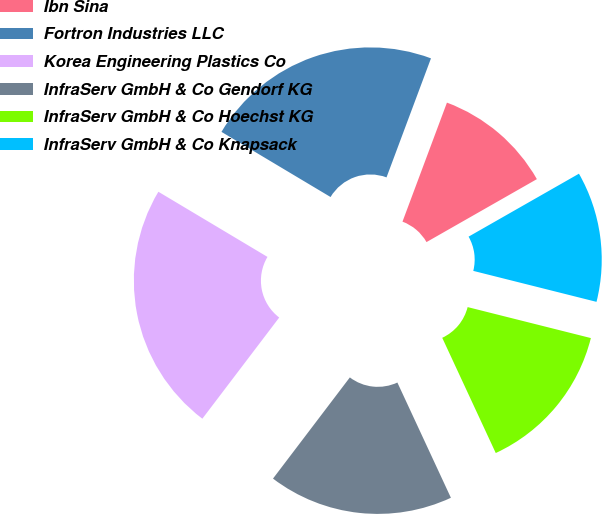<chart> <loc_0><loc_0><loc_500><loc_500><pie_chart><fcel>Ibn Sina<fcel>Fortron Industries LLC<fcel>Korea Engineering Plastics Co<fcel>InfraServ GmbH & Co Gendorf KG<fcel>InfraServ GmbH & Co Hoechst KG<fcel>InfraServ GmbH & Co Knapsack<nl><fcel>11.06%<fcel>22.12%<fcel>23.23%<fcel>17.26%<fcel>14.16%<fcel>12.17%<nl></chart> 